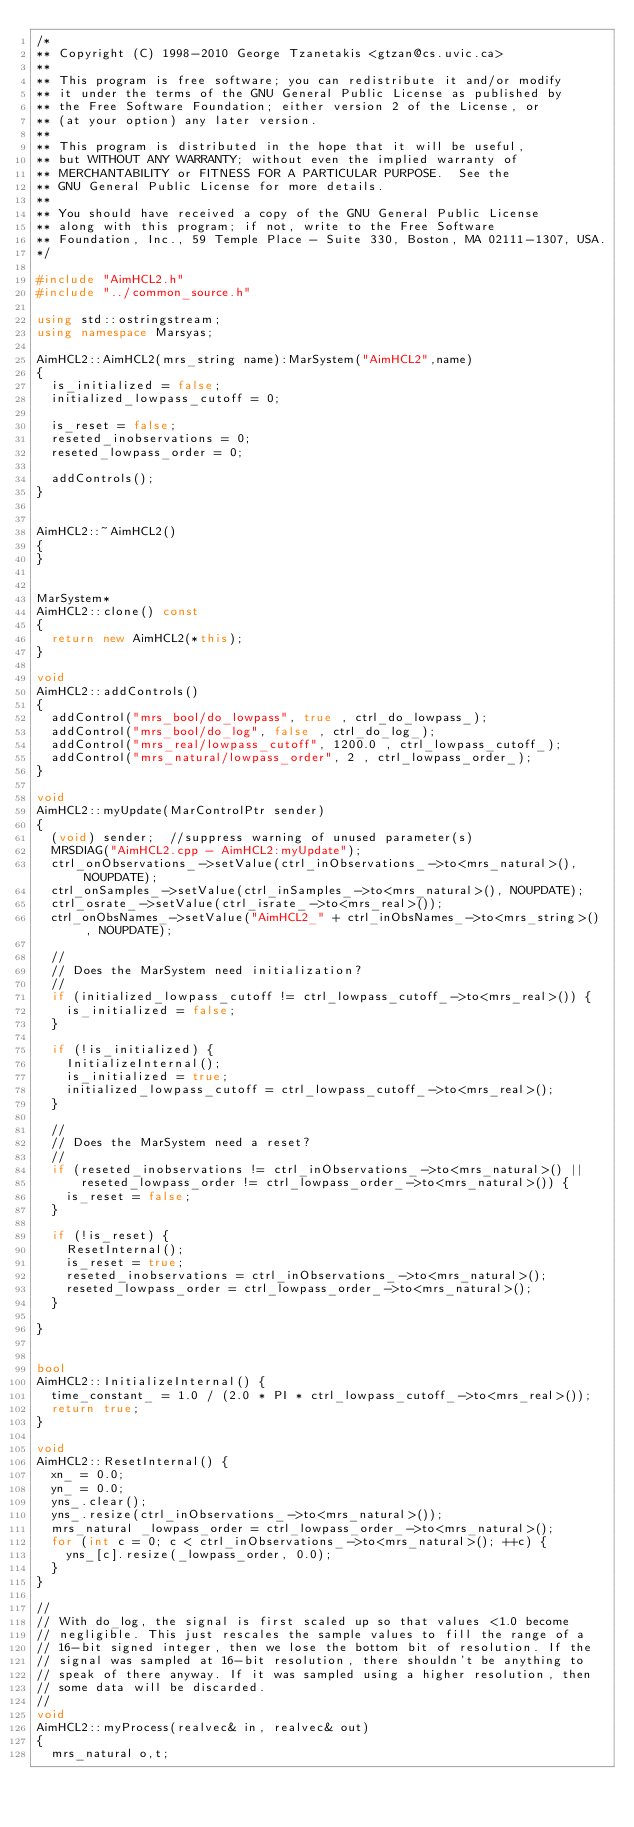<code> <loc_0><loc_0><loc_500><loc_500><_C++_>/*
** Copyright (C) 1998-2010 George Tzanetakis <gtzan@cs.uvic.ca>
**
** This program is free software; you can redistribute it and/or modify
** it under the terms of the GNU General Public License as published by
** the Free Software Foundation; either version 2 of the License, or
** (at your option) any later version.
**
** This program is distributed in the hope that it will be useful,
** but WITHOUT ANY WARRANTY; without even the implied warranty of
** MERCHANTABILITY or FITNESS FOR A PARTICULAR PURPOSE.  See the
** GNU General Public License for more details.
**
** You should have received a copy of the GNU General Public License
** along with this program; if not, write to the Free Software
** Foundation, Inc., 59 Temple Place - Suite 330, Boston, MA 02111-1307, USA.
*/

#include "AimHCL2.h"
#include "../common_source.h"

using std::ostringstream;
using namespace Marsyas;

AimHCL2::AimHCL2(mrs_string name):MarSystem("AimHCL2",name)
{
  is_initialized = false;
  initialized_lowpass_cutoff = 0;

  is_reset = false;
  reseted_inobservations = 0;
  reseted_lowpass_order = 0;

  addControls();
}


AimHCL2::~AimHCL2()
{
}


MarSystem*
AimHCL2::clone() const
{
  return new AimHCL2(*this);
}

void
AimHCL2::addControls()
{
  addControl("mrs_bool/do_lowpass", true , ctrl_do_lowpass_);
  addControl("mrs_bool/do_log", false , ctrl_do_log_);
  addControl("mrs_real/lowpass_cutoff", 1200.0 , ctrl_lowpass_cutoff_);
  addControl("mrs_natural/lowpass_order", 2 , ctrl_lowpass_order_);
}

void
AimHCL2::myUpdate(MarControlPtr sender)
{
  (void) sender;  //suppress warning of unused parameter(s)
  MRSDIAG("AimHCL2.cpp - AimHCL2:myUpdate");
  ctrl_onObservations_->setValue(ctrl_inObservations_->to<mrs_natural>(), NOUPDATE);
  ctrl_onSamples_->setValue(ctrl_inSamples_->to<mrs_natural>(), NOUPDATE);
  ctrl_osrate_->setValue(ctrl_israte_->to<mrs_real>());
  ctrl_onObsNames_->setValue("AimHCL2_" + ctrl_inObsNames_->to<mrs_string>() , NOUPDATE);

  //
  // Does the MarSystem need initialization?
  //
  if (initialized_lowpass_cutoff != ctrl_lowpass_cutoff_->to<mrs_real>()) {
    is_initialized = false;
  }

  if (!is_initialized) {
    InitializeInternal();
    is_initialized = true;
    initialized_lowpass_cutoff = ctrl_lowpass_cutoff_->to<mrs_real>();
  }

  //
  // Does the MarSystem need a reset?
  //
  if (reseted_inobservations != ctrl_inObservations_->to<mrs_natural>() ||
      reseted_lowpass_order != ctrl_lowpass_order_->to<mrs_natural>()) {
    is_reset = false;
  }

  if (!is_reset) {
    ResetInternal();
    is_reset = true;
    reseted_inobservations = ctrl_inObservations_->to<mrs_natural>();
    reseted_lowpass_order = ctrl_lowpass_order_->to<mrs_natural>();
  }

}


bool
AimHCL2::InitializeInternal() {
  time_constant_ = 1.0 / (2.0 * PI * ctrl_lowpass_cutoff_->to<mrs_real>());
  return true;
}

void
AimHCL2::ResetInternal() {
  xn_ = 0.0;
  yn_ = 0.0;
  yns_.clear();
  yns_.resize(ctrl_inObservations_->to<mrs_natural>());
  mrs_natural _lowpass_order = ctrl_lowpass_order_->to<mrs_natural>();
  for (int c = 0; c < ctrl_inObservations_->to<mrs_natural>(); ++c) {
    yns_[c].resize(_lowpass_order, 0.0);
  }
}

//
// With do_log, the signal is first scaled up so that values <1.0 become
// negligible. This just rescales the sample values to fill the range of a
// 16-bit signed integer, then we lose the bottom bit of resolution. If the
// signal was sampled at 16-bit resolution, there shouldn't be anything to
// speak of there anyway. If it was sampled using a higher resolution, then
// some data will be discarded.
//
void
AimHCL2::myProcess(realvec& in, realvec& out)
{
  mrs_natural o,t;</code> 